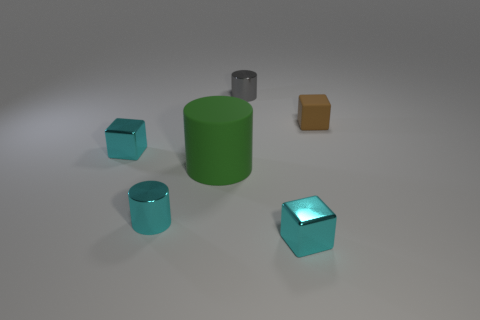Subtract all tiny metal blocks. How many blocks are left? 1 Add 1 large things. How many objects exist? 7 Subtract 1 blocks. How many blocks are left? 2 Subtract all gray cylinders. How many cylinders are left? 2 Add 6 yellow things. How many yellow things exist? 6 Subtract 0 yellow cylinders. How many objects are left? 6 Subtract all brown cylinders. Subtract all cyan blocks. How many cylinders are left? 3 Subtract all purple balls. How many gray cubes are left? 0 Subtract all tiny purple blocks. Subtract all green rubber cylinders. How many objects are left? 5 Add 4 small shiny cylinders. How many small shiny cylinders are left? 6 